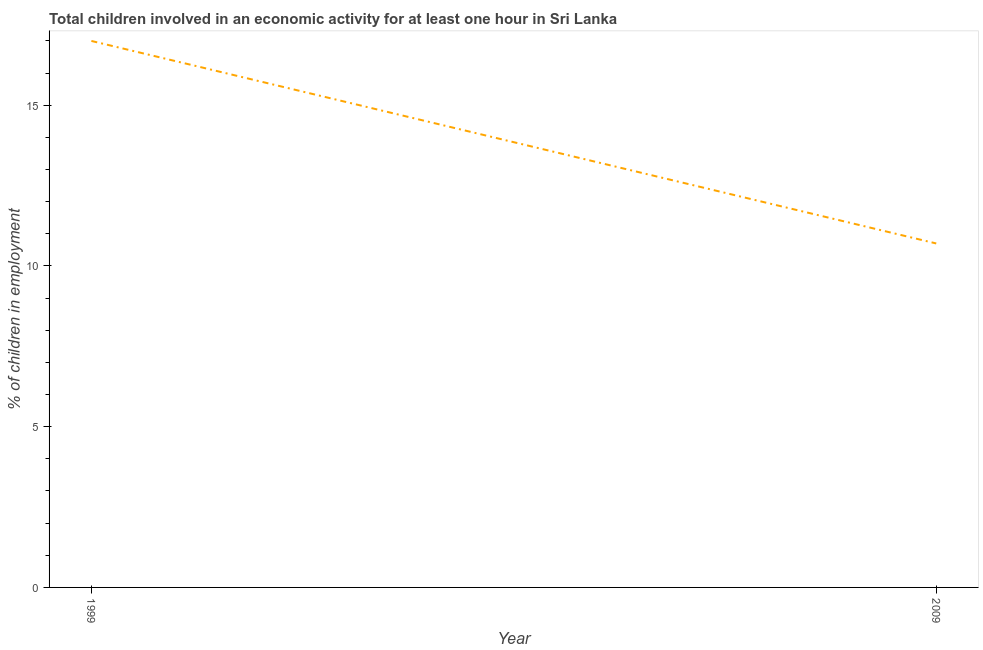Across all years, what is the maximum percentage of children in employment?
Offer a terse response. 17. In which year was the percentage of children in employment minimum?
Give a very brief answer. 2009. What is the sum of the percentage of children in employment?
Keep it short and to the point. 27.7. What is the difference between the percentage of children in employment in 1999 and 2009?
Your answer should be very brief. 6.3. What is the average percentage of children in employment per year?
Offer a very short reply. 13.85. What is the median percentage of children in employment?
Ensure brevity in your answer.  13.85. In how many years, is the percentage of children in employment greater than 2 %?
Offer a very short reply. 2. What is the ratio of the percentage of children in employment in 1999 to that in 2009?
Give a very brief answer. 1.59. Is the percentage of children in employment in 1999 less than that in 2009?
Ensure brevity in your answer.  No. How many years are there in the graph?
Provide a short and direct response. 2. Are the values on the major ticks of Y-axis written in scientific E-notation?
Offer a terse response. No. What is the title of the graph?
Provide a short and direct response. Total children involved in an economic activity for at least one hour in Sri Lanka. What is the label or title of the Y-axis?
Your response must be concise. % of children in employment. What is the % of children in employment in 2009?
Offer a terse response. 10.7. What is the difference between the % of children in employment in 1999 and 2009?
Offer a very short reply. 6.3. What is the ratio of the % of children in employment in 1999 to that in 2009?
Provide a succinct answer. 1.59. 